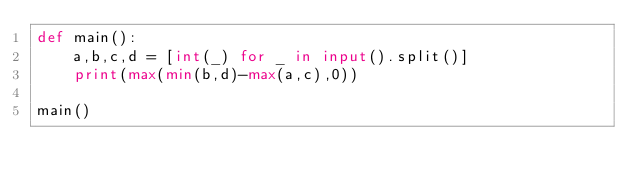<code> <loc_0><loc_0><loc_500><loc_500><_Python_>def main():
    a,b,c,d = [int(_) for _ in input().split()]
    print(max(min(b,d)-max(a,c),0))
    
main()</code> 